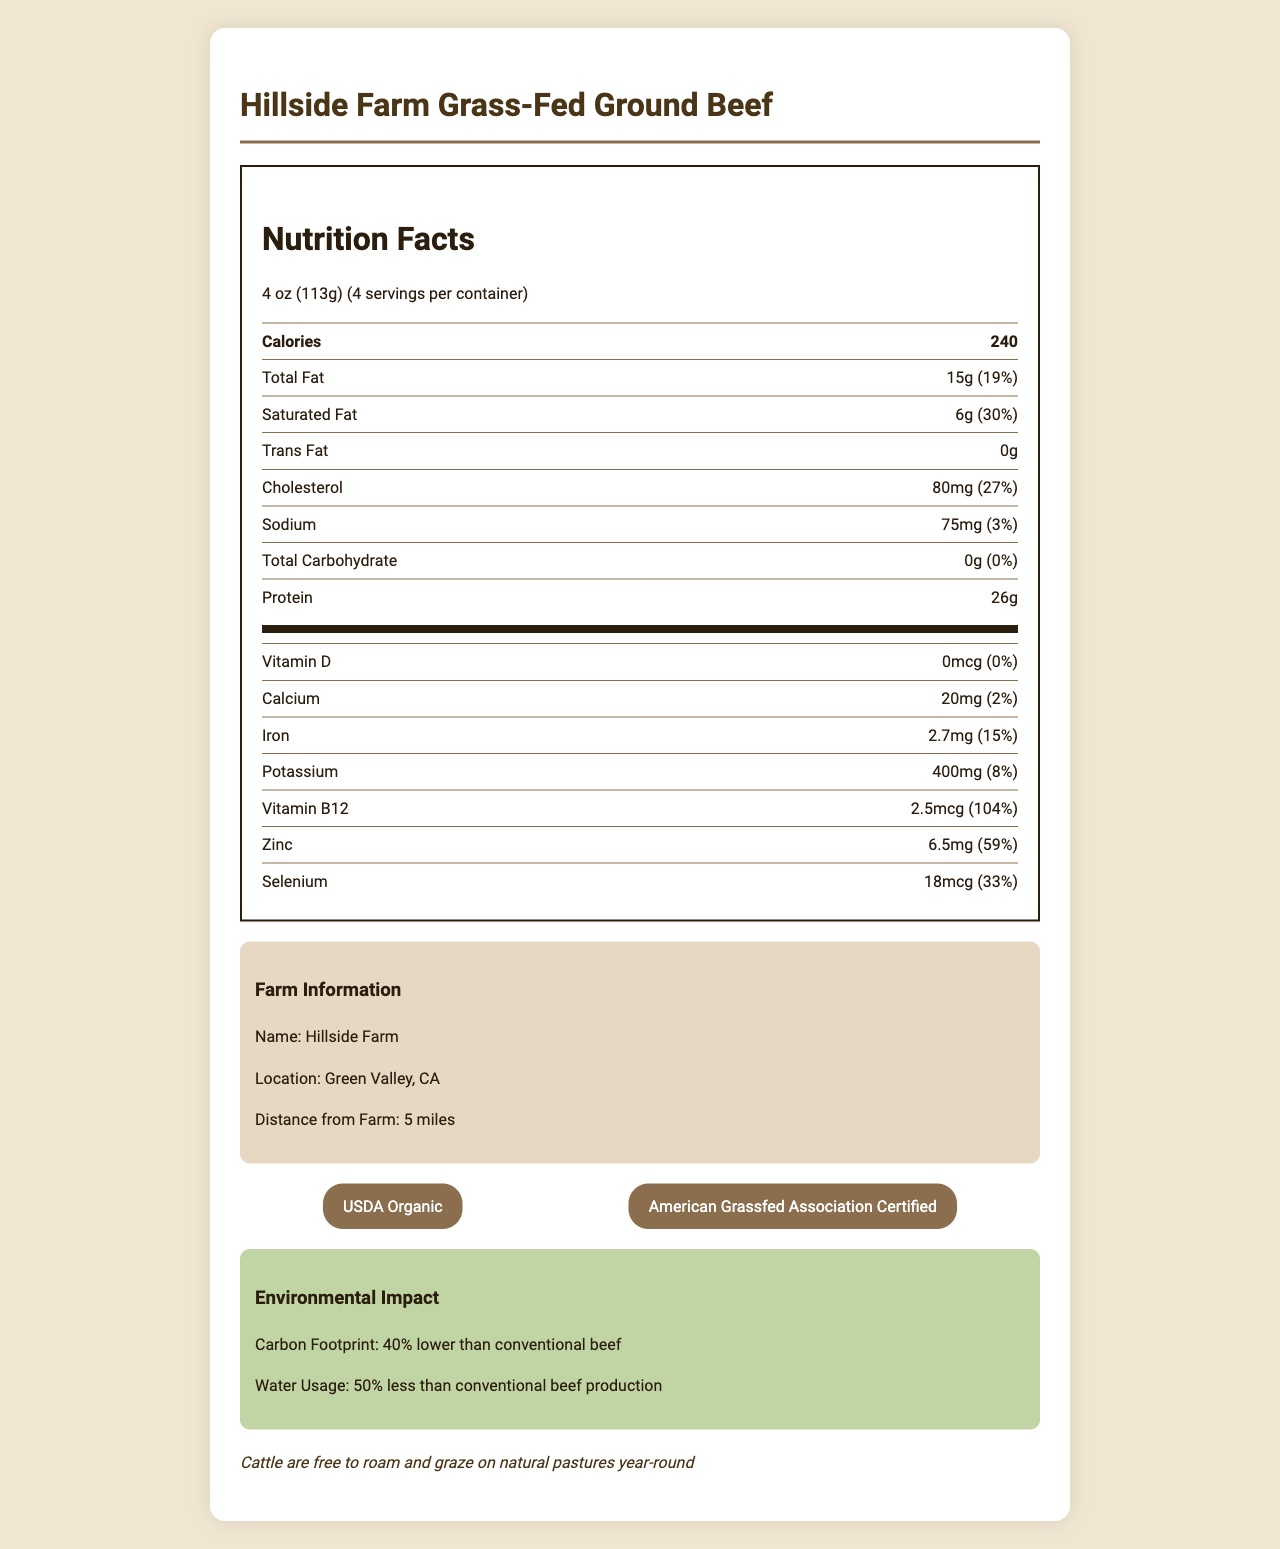what is the serving size of the beef? The serving size is located at the top section of the Nutrition Facts label.
Answer: 4 oz (113g) does the beef contain any added sugars? The additional information for added sugars shows 0g, indicating no added sugars.
Answer: No what is the total fat content per serving and its daily value percentage? The total fat content per serving is 15g, and the daily value percentage is 19%, as noted in the Nutrition Facts.
Answer: 15g, 19% how much cholesterol is in one serving? The cholesterol content per serving is clearly stated as 80mg in the Nutrition Facts.
Answer: 80mg how many servings are there per container? The Nutrition Facts label states that there are 4 servings per container.
Answer: 4 what certifications does Hillside Farm Grass-Fed Ground Beef have? A. USDA Organic B. American Grassfed Association Certified C. Non-GMO Verified D. Certified Humane E. Both A and B The beef is certified by USDA Organic and American Grassfed Association Certified, as listed in the certifications section.
Answer: E what is the sodium content and its daily value percentage? A. 50mg, 2% B. 75mg, 3% C. 100mg, 4% The sodium content per serving is 75mg and the daily value percentage is 3%, as mentioned in the Nutrition Facts.
Answer: B is there any trans fat in this beef? The Nutrition Facts show 0g trans fat, indicating there is none.
Answer: No what information is provided about environmental impact? The environmental impact section provides these specific details.
Answer: The beef has a carbon footprint 40% lower than conventional beef and uses 50% less water. what is the main idea of the document? The main idea encompasses the nutritional content, origin, certifications, and ecological and ethical aspects of the beef product.
Answer: The document provides detailed Nutrition Facts, farm information, certifications, and environmental and animal welfare benefits of Hillside Farm Grass-Fed Ground Beef. how does the beef compare to conventional beef in terms of omega-3 fatty acids content? The document mentions that the beef is higher in omega-3 fatty acids than conventional beef, but it doesn't provide specific numerical data to make a direct comparison.
Answer: Not enough information 